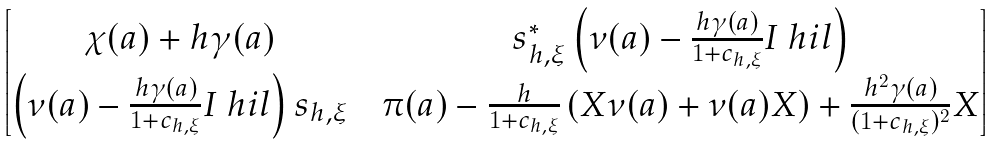Convert formula to latex. <formula><loc_0><loc_0><loc_500><loc_500>\begin{bmatrix} \chi ( a ) + h \gamma ( a ) & & s _ { h , \xi } ^ { * } \left ( \nu ( a ) - \frac { h \gamma ( a ) } { 1 + c _ { h , \xi } } I _ { \ } h i l \right ) \\ \left ( \nu ( a ) - \frac { h \gamma ( a ) } { 1 + c _ { h , \xi } } I _ { \ } h i l \right ) s _ { h , \xi } & & \pi ( a ) - \frac { h } { 1 + c _ { h , \xi } } \left ( X \nu ( a ) + \nu ( a ) X \right ) + \frac { h ^ { 2 } \gamma ( a ) } { ( 1 + c _ { h , \xi } ) ^ { 2 } } X \end{bmatrix}</formula> 